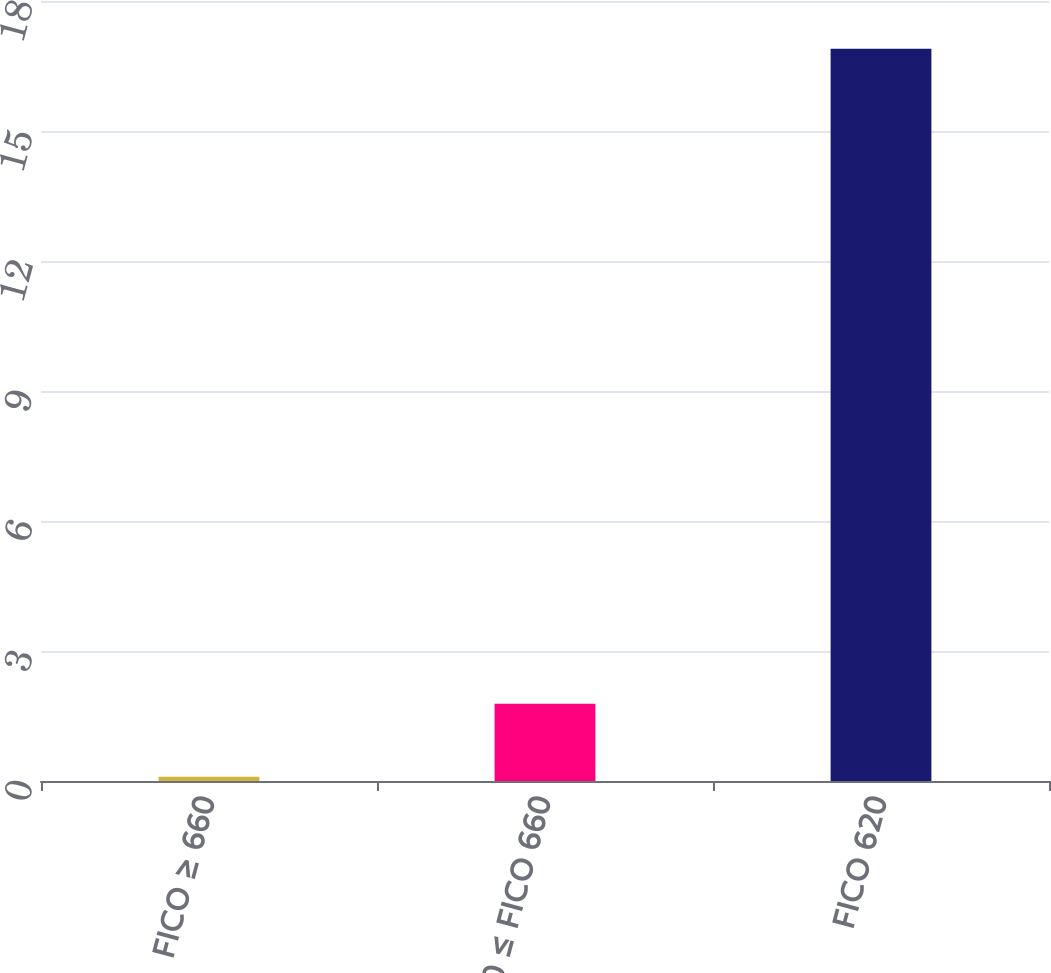Convert chart to OTSL. <chart><loc_0><loc_0><loc_500><loc_500><bar_chart><fcel>FICO ≥ 660<fcel>620 ≤ FICO 660<fcel>FICO 620<nl><fcel>0.1<fcel>1.78<fcel>16.9<nl></chart> 